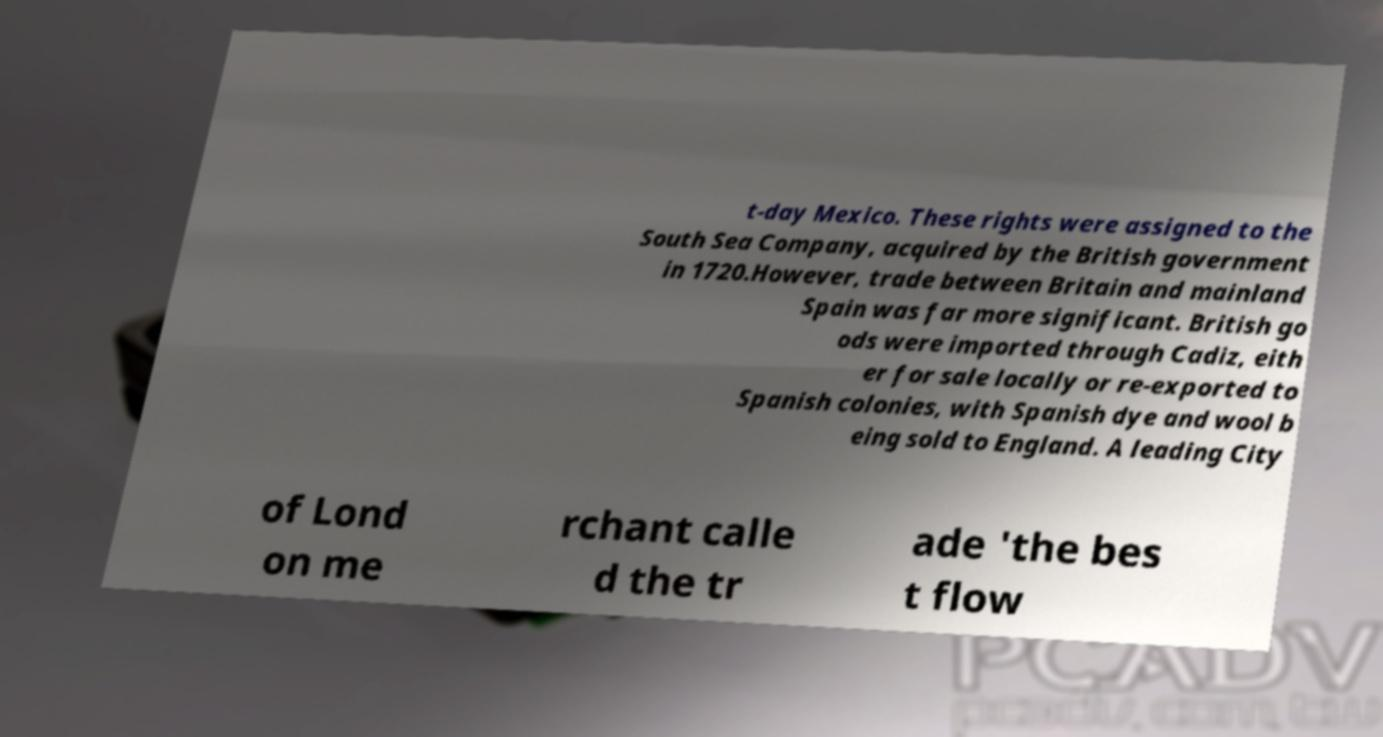Can you accurately transcribe the text from the provided image for me? t-day Mexico. These rights were assigned to the South Sea Company, acquired by the British government in 1720.However, trade between Britain and mainland Spain was far more significant. British go ods were imported through Cadiz, eith er for sale locally or re-exported to Spanish colonies, with Spanish dye and wool b eing sold to England. A leading City of Lond on me rchant calle d the tr ade 'the bes t flow 